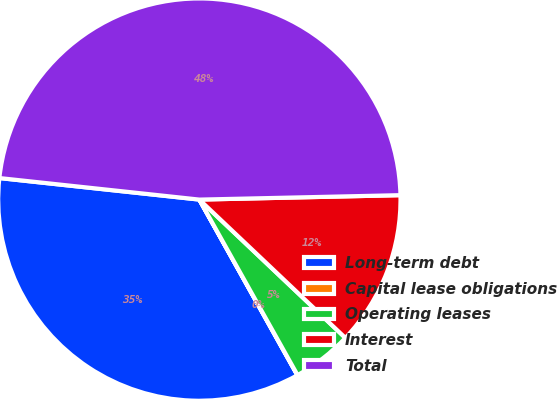Convert chart. <chart><loc_0><loc_0><loc_500><loc_500><pie_chart><fcel>Long-term debt<fcel>Capital lease obligations<fcel>Operating leases<fcel>Interest<fcel>Total<nl><fcel>34.81%<fcel>0.02%<fcel>4.81%<fcel>12.42%<fcel>47.94%<nl></chart> 